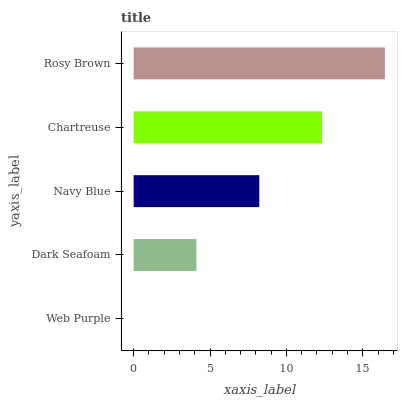Is Web Purple the minimum?
Answer yes or no. Yes. Is Rosy Brown the maximum?
Answer yes or no. Yes. Is Dark Seafoam the minimum?
Answer yes or no. No. Is Dark Seafoam the maximum?
Answer yes or no. No. Is Dark Seafoam greater than Web Purple?
Answer yes or no. Yes. Is Web Purple less than Dark Seafoam?
Answer yes or no. Yes. Is Web Purple greater than Dark Seafoam?
Answer yes or no. No. Is Dark Seafoam less than Web Purple?
Answer yes or no. No. Is Navy Blue the high median?
Answer yes or no. Yes. Is Navy Blue the low median?
Answer yes or no. Yes. Is Chartreuse the high median?
Answer yes or no. No. Is Chartreuse the low median?
Answer yes or no. No. 